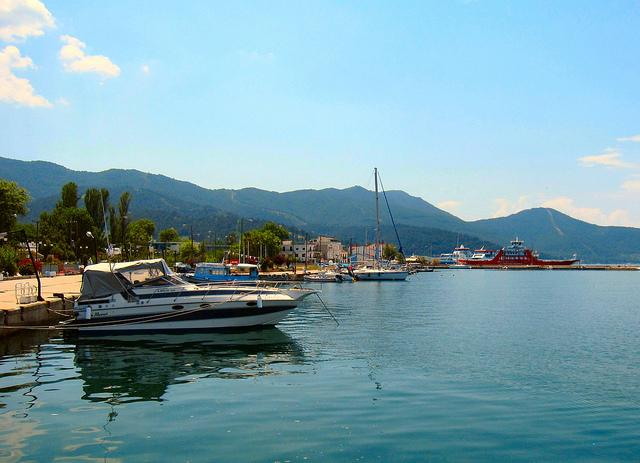What can usually be found in this setting?

Choices:
A) tigers
B) camels
C) horses
D) fish fish 